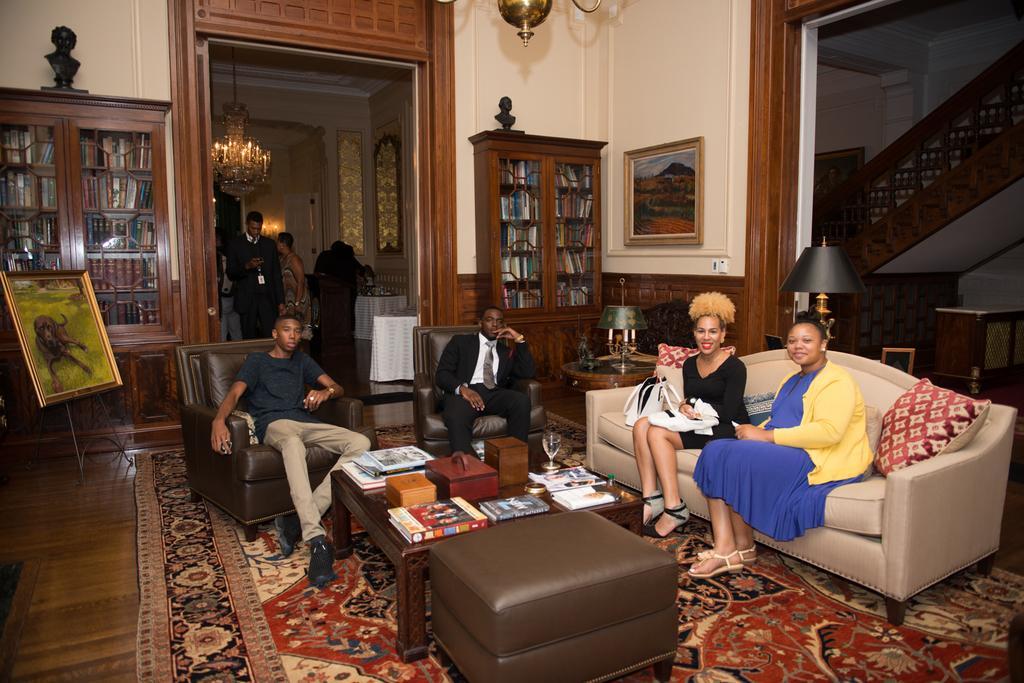Please provide a concise description of this image. In the image we can see there are people who are sitting on chair and sofa and on the back there are people who are standing. Behind there are shelves in which books are kept. On the wall there are photo frames and here on the stand there is a painting. On the table there are boxes, wine glass, papers, books and on the floor there is floor mat. 